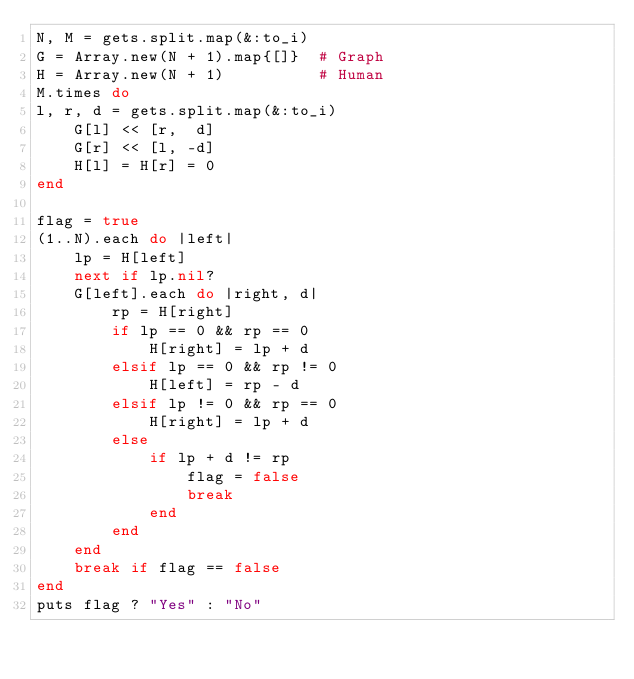<code> <loc_0><loc_0><loc_500><loc_500><_Ruby_>N, M = gets.split.map(&:to_i)
G = Array.new(N + 1).map{[]}  # Graph
H = Array.new(N + 1)          # Human
M.times do 
l, r, d = gets.split.map(&:to_i)
    G[l] << [r,  d]
    G[r] << [l, -d]
    H[l] = H[r] = 0
end

flag = true
(1..N).each do |left|
    lp = H[left]
    next if lp.nil?
    G[left].each do |right, d|
        rp = H[right]
        if lp == 0 && rp == 0
            H[right] = lp + d
        elsif lp == 0 && rp != 0
            H[left] = rp - d
        elsif lp != 0 && rp == 0
            H[right] = lp + d
        else
            if lp + d != rp
                flag = false
                break
            end
        end
    end
    break if flag == false
end
puts flag ? "Yes" : "No"

           
</code> 